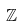<formula> <loc_0><loc_0><loc_500><loc_500>\mathbb { Z }</formula> 